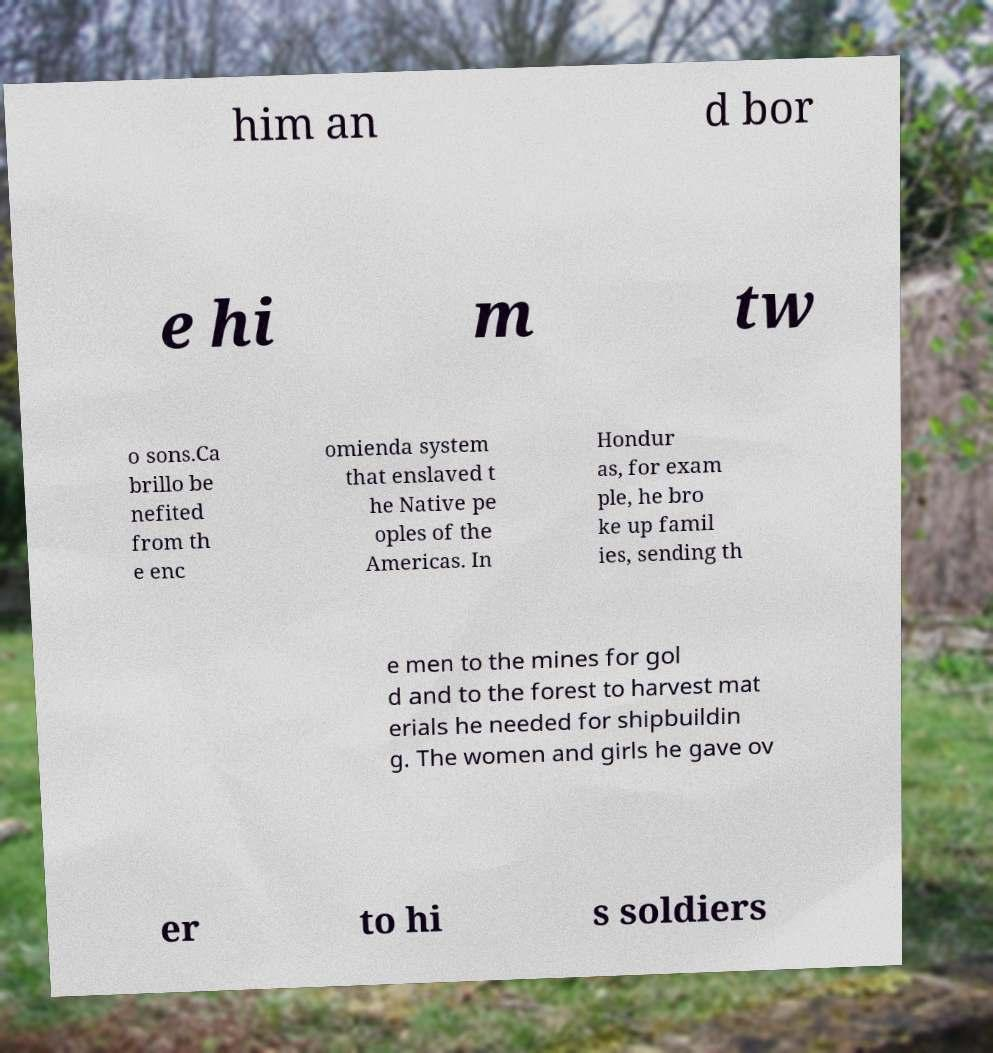Could you assist in decoding the text presented in this image and type it out clearly? him an d bor e hi m tw o sons.Ca brillo be nefited from th e enc omienda system that enslaved t he Native pe oples of the Americas. In Hondur as, for exam ple, he bro ke up famil ies, sending th e men to the mines for gol d and to the forest to harvest mat erials he needed for shipbuildin g. The women and girls he gave ov er to hi s soldiers 